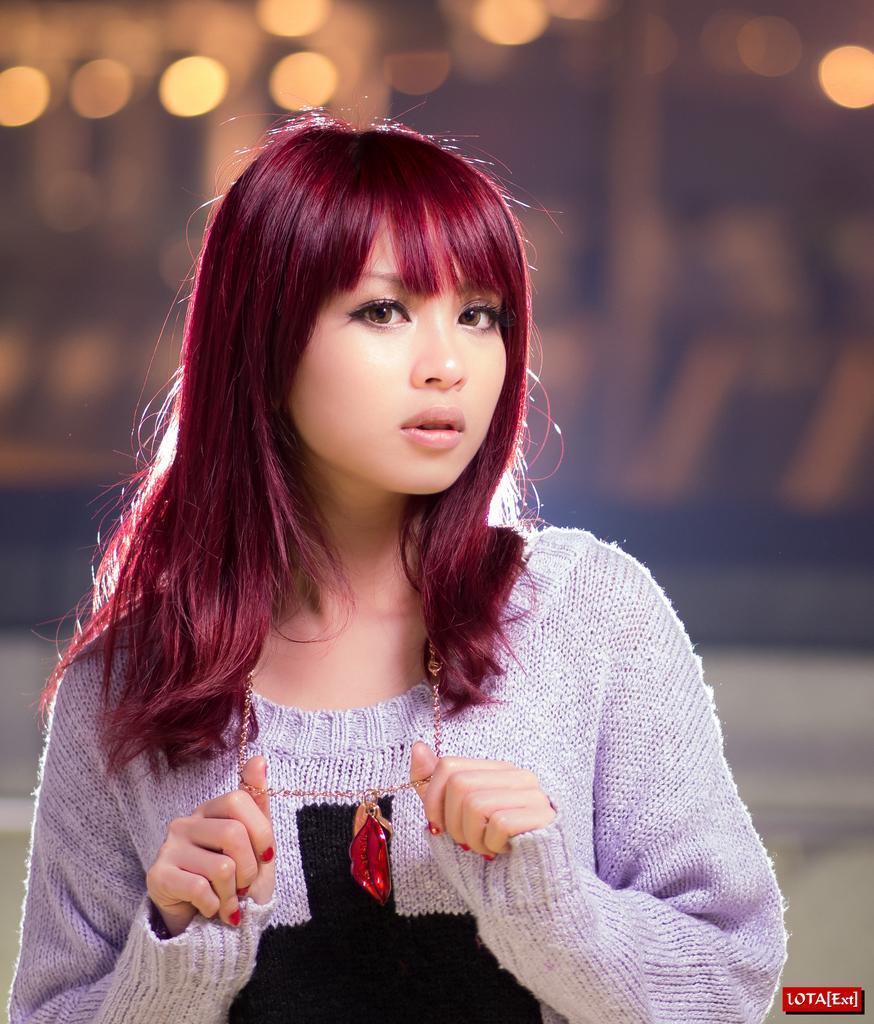How would you summarize this image in a sentence or two? In the center of the image, we can see a lady and in the background, there are lights. At the bottom, there is some text. 